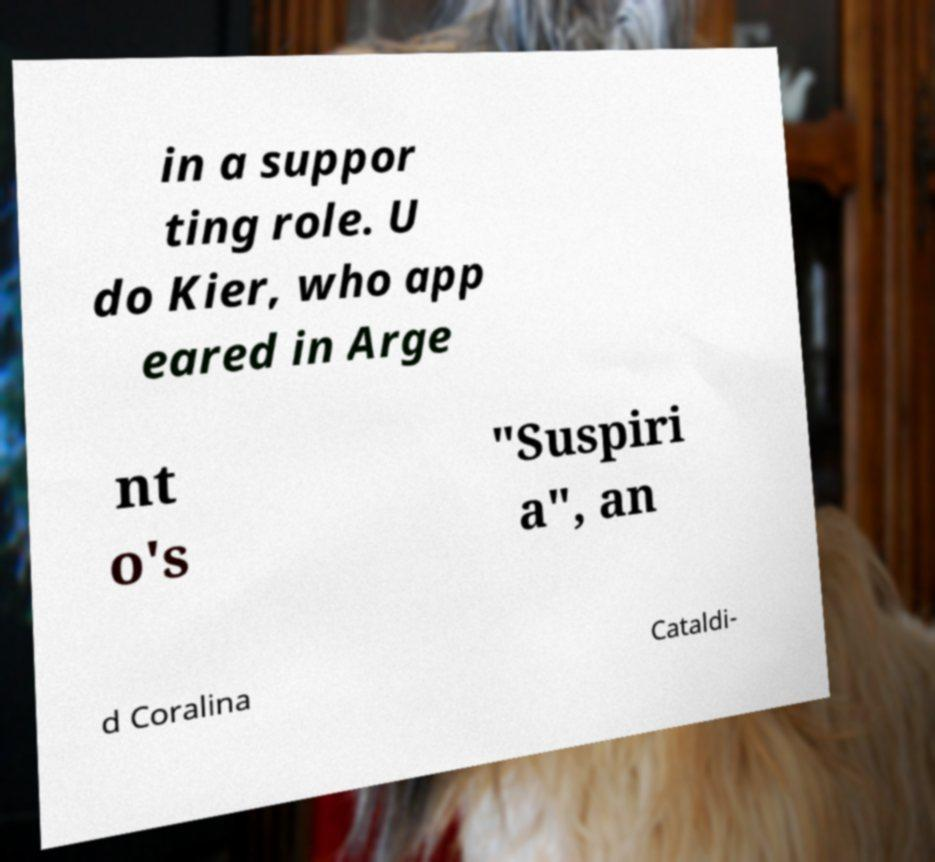I need the written content from this picture converted into text. Can you do that? in a suppor ting role. U do Kier, who app eared in Arge nt o's "Suspiri a", an d Coralina Cataldi- 